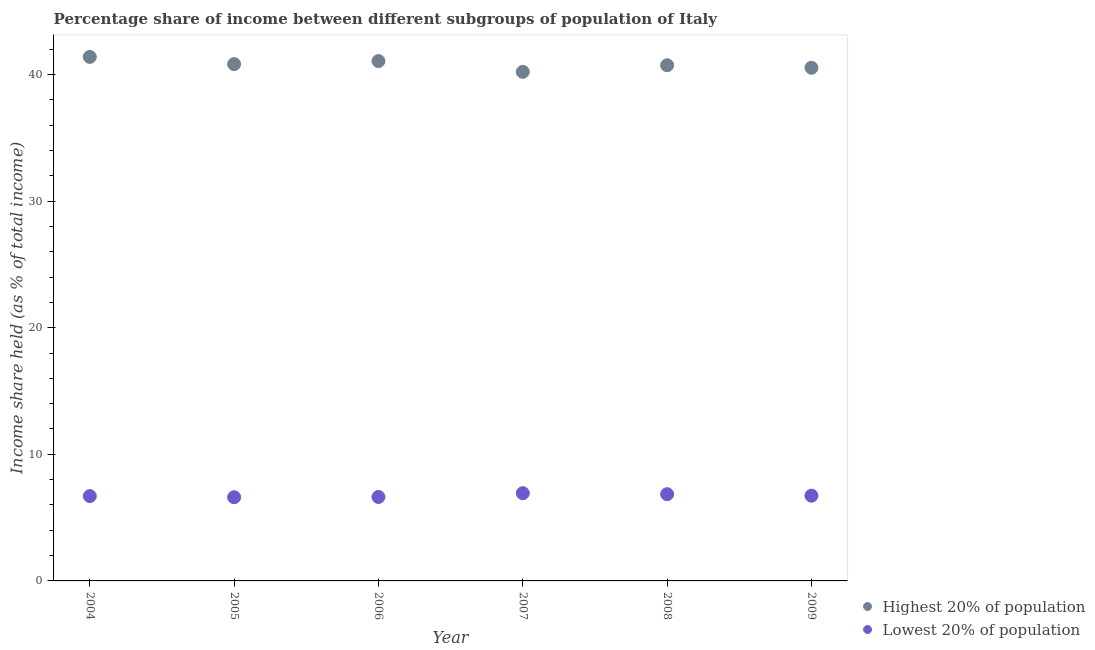How many different coloured dotlines are there?
Your response must be concise. 2. Is the number of dotlines equal to the number of legend labels?
Your answer should be very brief. Yes. What is the income share held by lowest 20% of the population in 2004?
Make the answer very short. 6.7. Across all years, what is the maximum income share held by lowest 20% of the population?
Make the answer very short. 6.93. Across all years, what is the minimum income share held by lowest 20% of the population?
Make the answer very short. 6.61. In which year was the income share held by lowest 20% of the population maximum?
Ensure brevity in your answer.  2007. In which year was the income share held by highest 20% of the population minimum?
Ensure brevity in your answer.  2007. What is the total income share held by lowest 20% of the population in the graph?
Make the answer very short. 40.45. What is the difference between the income share held by highest 20% of the population in 2007 and that in 2008?
Make the answer very short. -0.52. What is the difference between the income share held by lowest 20% of the population in 2004 and the income share held by highest 20% of the population in 2005?
Make the answer very short. -34.12. What is the average income share held by lowest 20% of the population per year?
Offer a very short reply. 6.74. In the year 2006, what is the difference between the income share held by highest 20% of the population and income share held by lowest 20% of the population?
Offer a terse response. 34.43. What is the ratio of the income share held by highest 20% of the population in 2006 to that in 2008?
Your answer should be very brief. 1.01. Is the income share held by highest 20% of the population in 2008 less than that in 2009?
Your answer should be compact. No. Is the difference between the income share held by highest 20% of the population in 2005 and 2007 greater than the difference between the income share held by lowest 20% of the population in 2005 and 2007?
Your answer should be very brief. Yes. What is the difference between the highest and the second highest income share held by lowest 20% of the population?
Provide a succinct answer. 0.08. What is the difference between the highest and the lowest income share held by highest 20% of the population?
Give a very brief answer. 1.18. In how many years, is the income share held by lowest 20% of the population greater than the average income share held by lowest 20% of the population taken over all years?
Give a very brief answer. 2. Is the sum of the income share held by lowest 20% of the population in 2004 and 2007 greater than the maximum income share held by highest 20% of the population across all years?
Offer a terse response. No. Does the income share held by highest 20% of the population monotonically increase over the years?
Give a very brief answer. No. Is the income share held by lowest 20% of the population strictly less than the income share held by highest 20% of the population over the years?
Keep it short and to the point. Yes. Does the graph contain any zero values?
Your answer should be very brief. No. Does the graph contain grids?
Your response must be concise. No. Where does the legend appear in the graph?
Make the answer very short. Bottom right. How many legend labels are there?
Offer a very short reply. 2. How are the legend labels stacked?
Ensure brevity in your answer.  Vertical. What is the title of the graph?
Offer a terse response. Percentage share of income between different subgroups of population of Italy. Does "GDP per capita" appear as one of the legend labels in the graph?
Give a very brief answer. No. What is the label or title of the Y-axis?
Keep it short and to the point. Income share held (as % of total income). What is the Income share held (as % of total income) in Highest 20% of population in 2004?
Your answer should be very brief. 41.39. What is the Income share held (as % of total income) in Highest 20% of population in 2005?
Offer a terse response. 40.82. What is the Income share held (as % of total income) of Lowest 20% of population in 2005?
Ensure brevity in your answer.  6.61. What is the Income share held (as % of total income) in Highest 20% of population in 2006?
Make the answer very short. 41.06. What is the Income share held (as % of total income) of Lowest 20% of population in 2006?
Provide a succinct answer. 6.63. What is the Income share held (as % of total income) in Highest 20% of population in 2007?
Provide a short and direct response. 40.21. What is the Income share held (as % of total income) of Lowest 20% of population in 2007?
Your answer should be very brief. 6.93. What is the Income share held (as % of total income) in Highest 20% of population in 2008?
Ensure brevity in your answer.  40.73. What is the Income share held (as % of total income) of Lowest 20% of population in 2008?
Give a very brief answer. 6.85. What is the Income share held (as % of total income) in Highest 20% of population in 2009?
Offer a terse response. 40.53. What is the Income share held (as % of total income) in Lowest 20% of population in 2009?
Provide a short and direct response. 6.73. Across all years, what is the maximum Income share held (as % of total income) in Highest 20% of population?
Ensure brevity in your answer.  41.39. Across all years, what is the maximum Income share held (as % of total income) of Lowest 20% of population?
Offer a terse response. 6.93. Across all years, what is the minimum Income share held (as % of total income) of Highest 20% of population?
Ensure brevity in your answer.  40.21. Across all years, what is the minimum Income share held (as % of total income) of Lowest 20% of population?
Your response must be concise. 6.61. What is the total Income share held (as % of total income) in Highest 20% of population in the graph?
Keep it short and to the point. 244.74. What is the total Income share held (as % of total income) in Lowest 20% of population in the graph?
Keep it short and to the point. 40.45. What is the difference between the Income share held (as % of total income) in Highest 20% of population in 2004 and that in 2005?
Your response must be concise. 0.57. What is the difference between the Income share held (as % of total income) of Lowest 20% of population in 2004 and that in 2005?
Keep it short and to the point. 0.09. What is the difference between the Income share held (as % of total income) in Highest 20% of population in 2004 and that in 2006?
Provide a succinct answer. 0.33. What is the difference between the Income share held (as % of total income) of Lowest 20% of population in 2004 and that in 2006?
Your response must be concise. 0.07. What is the difference between the Income share held (as % of total income) in Highest 20% of population in 2004 and that in 2007?
Offer a terse response. 1.18. What is the difference between the Income share held (as % of total income) in Lowest 20% of population in 2004 and that in 2007?
Your answer should be compact. -0.23. What is the difference between the Income share held (as % of total income) of Highest 20% of population in 2004 and that in 2008?
Make the answer very short. 0.66. What is the difference between the Income share held (as % of total income) of Lowest 20% of population in 2004 and that in 2008?
Keep it short and to the point. -0.15. What is the difference between the Income share held (as % of total income) of Highest 20% of population in 2004 and that in 2009?
Give a very brief answer. 0.86. What is the difference between the Income share held (as % of total income) in Lowest 20% of population in 2004 and that in 2009?
Ensure brevity in your answer.  -0.03. What is the difference between the Income share held (as % of total income) in Highest 20% of population in 2005 and that in 2006?
Your answer should be compact. -0.24. What is the difference between the Income share held (as % of total income) of Lowest 20% of population in 2005 and that in 2006?
Ensure brevity in your answer.  -0.02. What is the difference between the Income share held (as % of total income) of Highest 20% of population in 2005 and that in 2007?
Offer a very short reply. 0.61. What is the difference between the Income share held (as % of total income) in Lowest 20% of population in 2005 and that in 2007?
Keep it short and to the point. -0.32. What is the difference between the Income share held (as % of total income) in Highest 20% of population in 2005 and that in 2008?
Provide a short and direct response. 0.09. What is the difference between the Income share held (as % of total income) in Lowest 20% of population in 2005 and that in 2008?
Your answer should be compact. -0.24. What is the difference between the Income share held (as % of total income) of Highest 20% of population in 2005 and that in 2009?
Offer a terse response. 0.29. What is the difference between the Income share held (as % of total income) in Lowest 20% of population in 2005 and that in 2009?
Provide a short and direct response. -0.12. What is the difference between the Income share held (as % of total income) in Highest 20% of population in 2006 and that in 2007?
Your response must be concise. 0.85. What is the difference between the Income share held (as % of total income) of Lowest 20% of population in 2006 and that in 2007?
Provide a succinct answer. -0.3. What is the difference between the Income share held (as % of total income) in Highest 20% of population in 2006 and that in 2008?
Your response must be concise. 0.33. What is the difference between the Income share held (as % of total income) of Lowest 20% of population in 2006 and that in 2008?
Provide a succinct answer. -0.22. What is the difference between the Income share held (as % of total income) of Highest 20% of population in 2006 and that in 2009?
Keep it short and to the point. 0.53. What is the difference between the Income share held (as % of total income) in Lowest 20% of population in 2006 and that in 2009?
Your response must be concise. -0.1. What is the difference between the Income share held (as % of total income) in Highest 20% of population in 2007 and that in 2008?
Your response must be concise. -0.52. What is the difference between the Income share held (as % of total income) in Highest 20% of population in 2007 and that in 2009?
Your answer should be very brief. -0.32. What is the difference between the Income share held (as % of total income) in Lowest 20% of population in 2008 and that in 2009?
Your response must be concise. 0.12. What is the difference between the Income share held (as % of total income) of Highest 20% of population in 2004 and the Income share held (as % of total income) of Lowest 20% of population in 2005?
Your answer should be compact. 34.78. What is the difference between the Income share held (as % of total income) in Highest 20% of population in 2004 and the Income share held (as % of total income) in Lowest 20% of population in 2006?
Provide a short and direct response. 34.76. What is the difference between the Income share held (as % of total income) in Highest 20% of population in 2004 and the Income share held (as % of total income) in Lowest 20% of population in 2007?
Provide a succinct answer. 34.46. What is the difference between the Income share held (as % of total income) in Highest 20% of population in 2004 and the Income share held (as % of total income) in Lowest 20% of population in 2008?
Give a very brief answer. 34.54. What is the difference between the Income share held (as % of total income) of Highest 20% of population in 2004 and the Income share held (as % of total income) of Lowest 20% of population in 2009?
Keep it short and to the point. 34.66. What is the difference between the Income share held (as % of total income) in Highest 20% of population in 2005 and the Income share held (as % of total income) in Lowest 20% of population in 2006?
Offer a terse response. 34.19. What is the difference between the Income share held (as % of total income) of Highest 20% of population in 2005 and the Income share held (as % of total income) of Lowest 20% of population in 2007?
Make the answer very short. 33.89. What is the difference between the Income share held (as % of total income) of Highest 20% of population in 2005 and the Income share held (as % of total income) of Lowest 20% of population in 2008?
Make the answer very short. 33.97. What is the difference between the Income share held (as % of total income) of Highest 20% of population in 2005 and the Income share held (as % of total income) of Lowest 20% of population in 2009?
Your response must be concise. 34.09. What is the difference between the Income share held (as % of total income) in Highest 20% of population in 2006 and the Income share held (as % of total income) in Lowest 20% of population in 2007?
Ensure brevity in your answer.  34.13. What is the difference between the Income share held (as % of total income) in Highest 20% of population in 2006 and the Income share held (as % of total income) in Lowest 20% of population in 2008?
Your answer should be compact. 34.21. What is the difference between the Income share held (as % of total income) of Highest 20% of population in 2006 and the Income share held (as % of total income) of Lowest 20% of population in 2009?
Make the answer very short. 34.33. What is the difference between the Income share held (as % of total income) in Highest 20% of population in 2007 and the Income share held (as % of total income) in Lowest 20% of population in 2008?
Give a very brief answer. 33.36. What is the difference between the Income share held (as % of total income) of Highest 20% of population in 2007 and the Income share held (as % of total income) of Lowest 20% of population in 2009?
Your answer should be compact. 33.48. What is the average Income share held (as % of total income) in Highest 20% of population per year?
Provide a succinct answer. 40.79. What is the average Income share held (as % of total income) of Lowest 20% of population per year?
Give a very brief answer. 6.74. In the year 2004, what is the difference between the Income share held (as % of total income) in Highest 20% of population and Income share held (as % of total income) in Lowest 20% of population?
Offer a very short reply. 34.69. In the year 2005, what is the difference between the Income share held (as % of total income) in Highest 20% of population and Income share held (as % of total income) in Lowest 20% of population?
Offer a very short reply. 34.21. In the year 2006, what is the difference between the Income share held (as % of total income) in Highest 20% of population and Income share held (as % of total income) in Lowest 20% of population?
Offer a very short reply. 34.43. In the year 2007, what is the difference between the Income share held (as % of total income) in Highest 20% of population and Income share held (as % of total income) in Lowest 20% of population?
Make the answer very short. 33.28. In the year 2008, what is the difference between the Income share held (as % of total income) in Highest 20% of population and Income share held (as % of total income) in Lowest 20% of population?
Give a very brief answer. 33.88. In the year 2009, what is the difference between the Income share held (as % of total income) in Highest 20% of population and Income share held (as % of total income) in Lowest 20% of population?
Your answer should be very brief. 33.8. What is the ratio of the Income share held (as % of total income) of Highest 20% of population in 2004 to that in 2005?
Your answer should be very brief. 1.01. What is the ratio of the Income share held (as % of total income) in Lowest 20% of population in 2004 to that in 2005?
Make the answer very short. 1.01. What is the ratio of the Income share held (as % of total income) of Lowest 20% of population in 2004 to that in 2006?
Give a very brief answer. 1.01. What is the ratio of the Income share held (as % of total income) in Highest 20% of population in 2004 to that in 2007?
Keep it short and to the point. 1.03. What is the ratio of the Income share held (as % of total income) in Lowest 20% of population in 2004 to that in 2007?
Ensure brevity in your answer.  0.97. What is the ratio of the Income share held (as % of total income) of Highest 20% of population in 2004 to that in 2008?
Provide a succinct answer. 1.02. What is the ratio of the Income share held (as % of total income) of Lowest 20% of population in 2004 to that in 2008?
Offer a very short reply. 0.98. What is the ratio of the Income share held (as % of total income) in Highest 20% of population in 2004 to that in 2009?
Your answer should be compact. 1.02. What is the ratio of the Income share held (as % of total income) of Lowest 20% of population in 2005 to that in 2006?
Provide a succinct answer. 1. What is the ratio of the Income share held (as % of total income) in Highest 20% of population in 2005 to that in 2007?
Your answer should be compact. 1.02. What is the ratio of the Income share held (as % of total income) of Lowest 20% of population in 2005 to that in 2007?
Make the answer very short. 0.95. What is the ratio of the Income share held (as % of total income) of Highest 20% of population in 2005 to that in 2008?
Give a very brief answer. 1. What is the ratio of the Income share held (as % of total income) in Lowest 20% of population in 2005 to that in 2008?
Keep it short and to the point. 0.96. What is the ratio of the Income share held (as % of total income) of Highest 20% of population in 2005 to that in 2009?
Your response must be concise. 1.01. What is the ratio of the Income share held (as % of total income) of Lowest 20% of population in 2005 to that in 2009?
Offer a terse response. 0.98. What is the ratio of the Income share held (as % of total income) in Highest 20% of population in 2006 to that in 2007?
Your answer should be very brief. 1.02. What is the ratio of the Income share held (as % of total income) of Lowest 20% of population in 2006 to that in 2007?
Provide a succinct answer. 0.96. What is the ratio of the Income share held (as % of total income) in Lowest 20% of population in 2006 to that in 2008?
Offer a very short reply. 0.97. What is the ratio of the Income share held (as % of total income) in Highest 20% of population in 2006 to that in 2009?
Ensure brevity in your answer.  1.01. What is the ratio of the Income share held (as % of total income) in Lowest 20% of population in 2006 to that in 2009?
Keep it short and to the point. 0.99. What is the ratio of the Income share held (as % of total income) in Highest 20% of population in 2007 to that in 2008?
Provide a short and direct response. 0.99. What is the ratio of the Income share held (as % of total income) of Lowest 20% of population in 2007 to that in 2008?
Keep it short and to the point. 1.01. What is the ratio of the Income share held (as % of total income) of Highest 20% of population in 2007 to that in 2009?
Ensure brevity in your answer.  0.99. What is the ratio of the Income share held (as % of total income) in Lowest 20% of population in 2007 to that in 2009?
Provide a succinct answer. 1.03. What is the ratio of the Income share held (as % of total income) of Lowest 20% of population in 2008 to that in 2009?
Ensure brevity in your answer.  1.02. What is the difference between the highest and the second highest Income share held (as % of total income) in Highest 20% of population?
Offer a very short reply. 0.33. What is the difference between the highest and the second highest Income share held (as % of total income) of Lowest 20% of population?
Offer a terse response. 0.08. What is the difference between the highest and the lowest Income share held (as % of total income) in Highest 20% of population?
Provide a succinct answer. 1.18. What is the difference between the highest and the lowest Income share held (as % of total income) of Lowest 20% of population?
Your response must be concise. 0.32. 